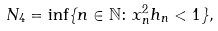Convert formula to latex. <formula><loc_0><loc_0><loc_500><loc_500>N _ { 4 } = \inf \{ n \in \mathbb { N } \colon x _ { n } ^ { 2 } h _ { n } < 1 \} ,</formula> 